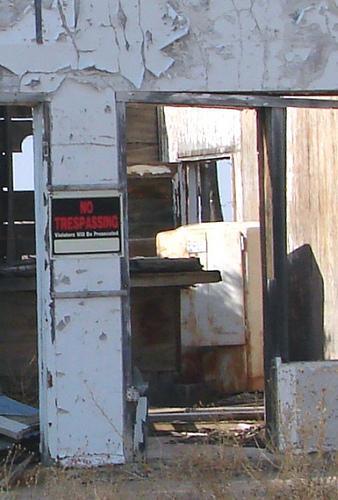How many signs are there?
Give a very brief answer. 1. 